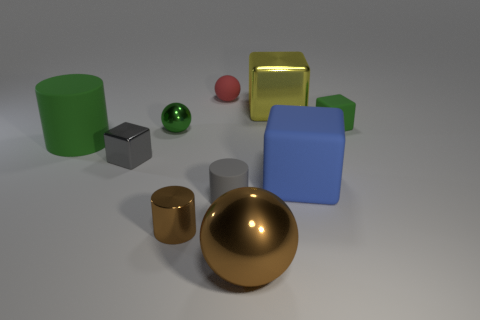Subtract all blocks. How many objects are left? 6 Add 4 big matte cylinders. How many big matte cylinders are left? 5 Add 1 large yellow cubes. How many large yellow cubes exist? 2 Subtract 1 brown cylinders. How many objects are left? 9 Subtract all big metal cylinders. Subtract all tiny metallic blocks. How many objects are left? 9 